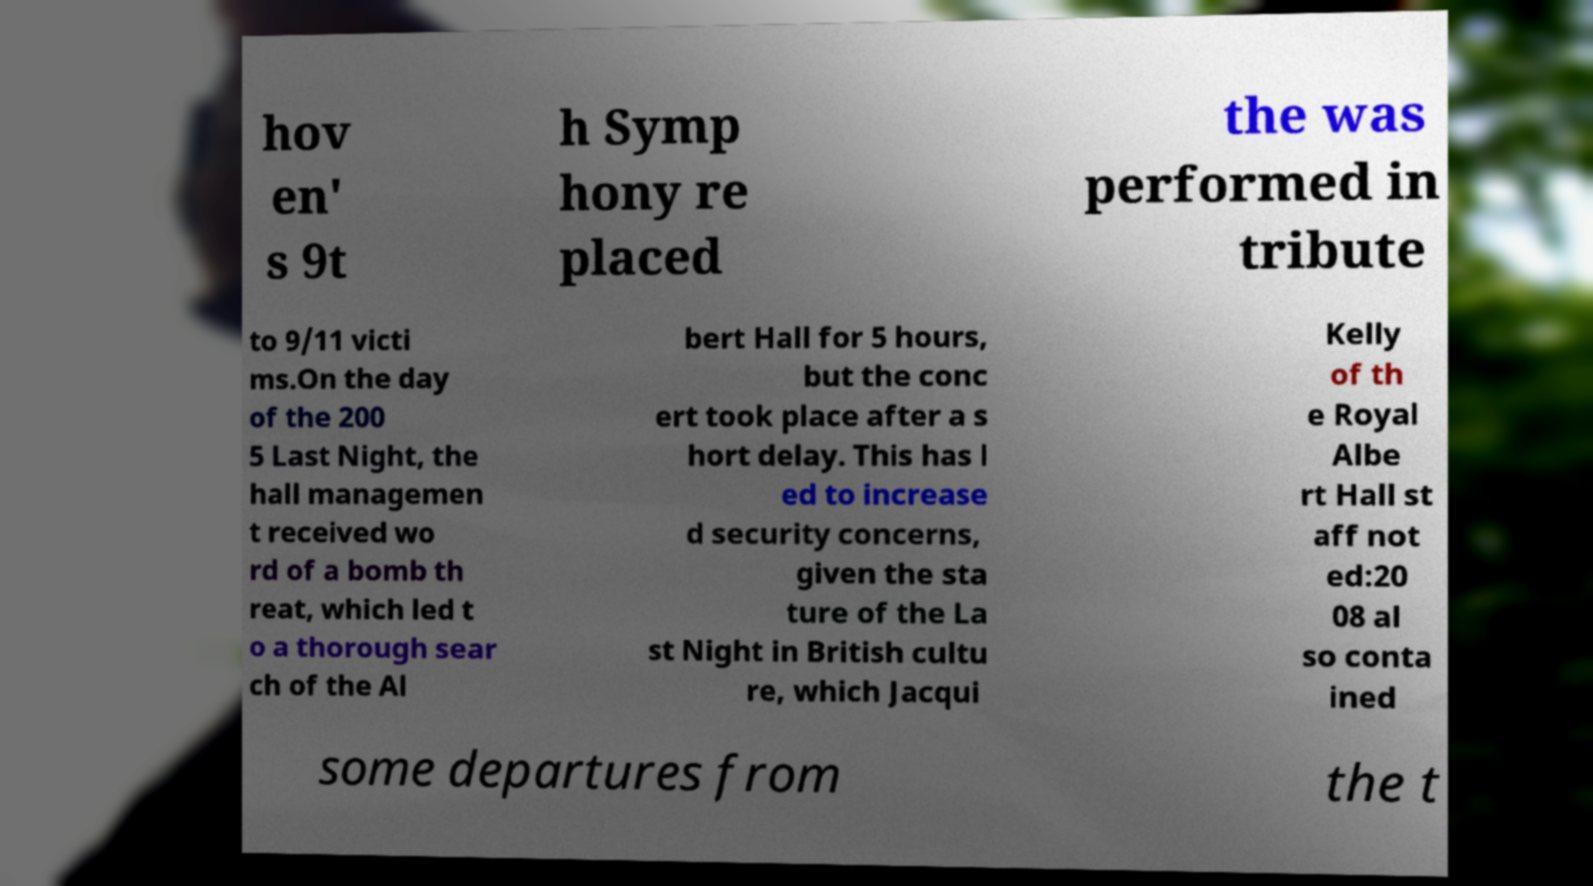There's text embedded in this image that I need extracted. Can you transcribe it verbatim? hov en' s 9t h Symp hony re placed the was performed in tribute to 9/11 victi ms.On the day of the 200 5 Last Night, the hall managemen t received wo rd of a bomb th reat, which led t o a thorough sear ch of the Al bert Hall for 5 hours, but the conc ert took place after a s hort delay. This has l ed to increase d security concerns, given the sta ture of the La st Night in British cultu re, which Jacqui Kelly of th e Royal Albe rt Hall st aff not ed:20 08 al so conta ined some departures from the t 